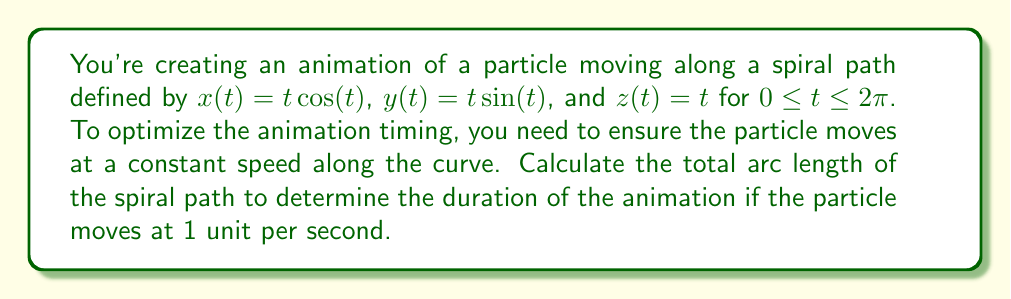Provide a solution to this math problem. To solve this problem, we'll follow these steps:

1) The arc length of a 3D curve is given by the formula:

   $$L = \int_a^b \sqrt{\left(\frac{dx}{dt}\right)^2 + \left(\frac{dy}{dt}\right)^2 + \left(\frac{dz}{dt}\right)^2} dt$$

2) First, let's find the derivatives:
   
   $\frac{dx}{dt} = \cos(t) - t\sin(t)$
   $\frac{dy}{dt} = \sin(t) + t\cos(t)$
   $\frac{dz}{dt} = 1$

3) Now, let's substitute these into our arc length formula:

   $$L = \int_0^{2\pi} \sqrt{(\cos(t) - t\sin(t))^2 + (\sin(t) + t\cos(t))^2 + 1^2} dt$$

4) Simplify the expression under the square root:

   $$(\cos(t) - t\sin(t))^2 + (\sin(t) + t\cos(t))^2 + 1^2$$
   $$= \cos^2(t) - 2t\cos(t)\sin(t) + t^2\sin^2(t) + \sin^2(t) + 2t\sin(t)\cos(t) + t^2\cos^2(t) + 1$$
   $$= \cos^2(t) + \sin^2(t) + t^2\sin^2(t) + t^2\cos^2(t) + 1$$
   $$= 1 + t^2 + 1 = t^2 + 2$$

5) Our integral now becomes:

   $$L = \int_0^{2\pi} \sqrt{t^2 + 2} dt$$

6) This integral doesn't have an elementary antiderivative. We can solve it using the substitution $t = \sqrt{2}\sinh(u)$:

   $$L = 2\int_0^{\sinh^{-1}(\pi/\sqrt{2})} \sqrt{2\sinh^2(u) + 2} \sqrt{2}\cosh(u) du$$
   $$= 2\sqrt{2}\int_0^{\sinh^{-1}(\pi/\sqrt{2})} \sqrt{\cosh^2(u)} \cosh(u) du$$
   $$= 2\sqrt{2}\int_0^{\sinh^{-1}(\pi/\sqrt{2})} \cosh^2(u) du$$

7) Using the identity $\cosh^2(u) = \frac{1}{2}(\cosh(2u) + 1)$, we get:

   $$L = \sqrt{2}\int_0^{\sinh^{-1}(\pi/\sqrt{2})} (\cosh(2u) + 1) du$$
   $$= \sqrt{2}\left[\frac{1}{2}\sinh(2u) + u\right]_0^{\sinh^{-1}(\pi/\sqrt{2})}$$

8) Evaluating this gives us:

   $$L = \sqrt{2}\left(\frac{1}{2}\sinh(2\sinh^{-1}(\pi/\sqrt{2})) + \sinh^{-1}(\pi/\sqrt{2})\right)$$

9) Simplify using $\sinh(2\sinh^{-1}(x)) = 2x\sqrt{1+x^2}$:

   $$L = \sqrt{2}\left(\frac{1}{2}\cdot 2\cdot \frac{\pi}{\sqrt{2}}\sqrt{1+(\pi/\sqrt{2})^2} + \sinh^{-1}(\pi/\sqrt{2})\right)$$
   $$= \pi\sqrt{1+\pi^2/2} + \sqrt{2}\sinh^{-1}(\pi/\sqrt{2})$$

This is the total arc length of the spiral. Since the particle moves at 1 unit per second, this value also represents the duration of the animation in seconds.
Answer: $\pi\sqrt{1+\pi^2/2} + \sqrt{2}\sinh^{-1}(\pi/\sqrt{2})$ seconds 